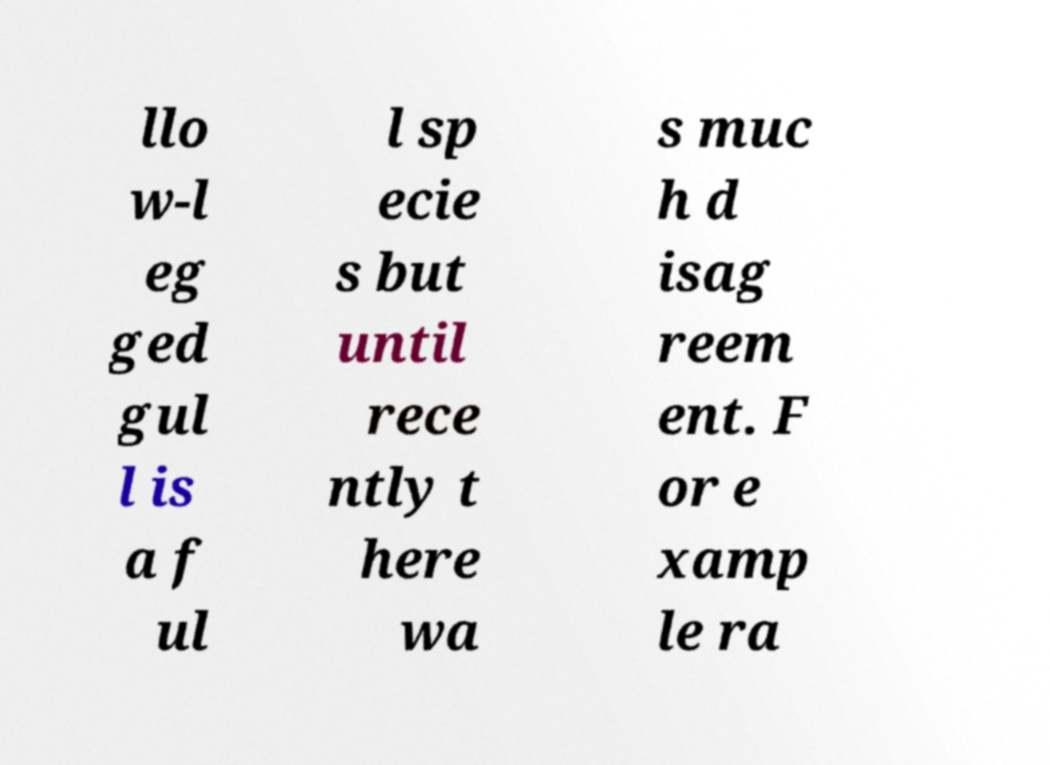What messages or text are displayed in this image? I need them in a readable, typed format. llo w-l eg ged gul l is a f ul l sp ecie s but until rece ntly t here wa s muc h d isag reem ent. F or e xamp le ra 